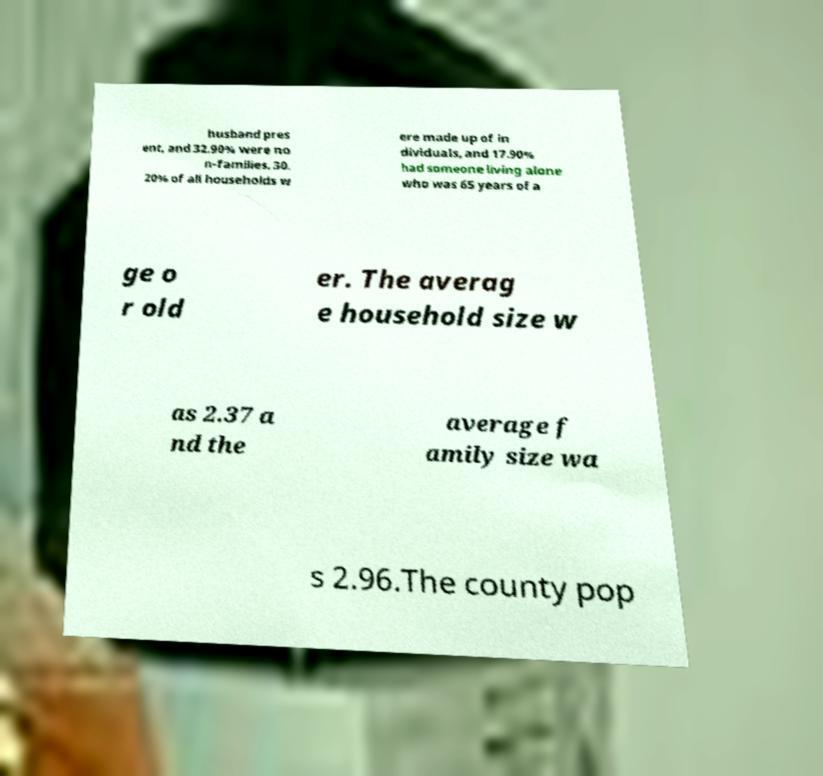I need the written content from this picture converted into text. Can you do that? husband pres ent, and 32.90% were no n-families. 30. 20% of all households w ere made up of in dividuals, and 17.90% had someone living alone who was 65 years of a ge o r old er. The averag e household size w as 2.37 a nd the average f amily size wa s 2.96.The county pop 